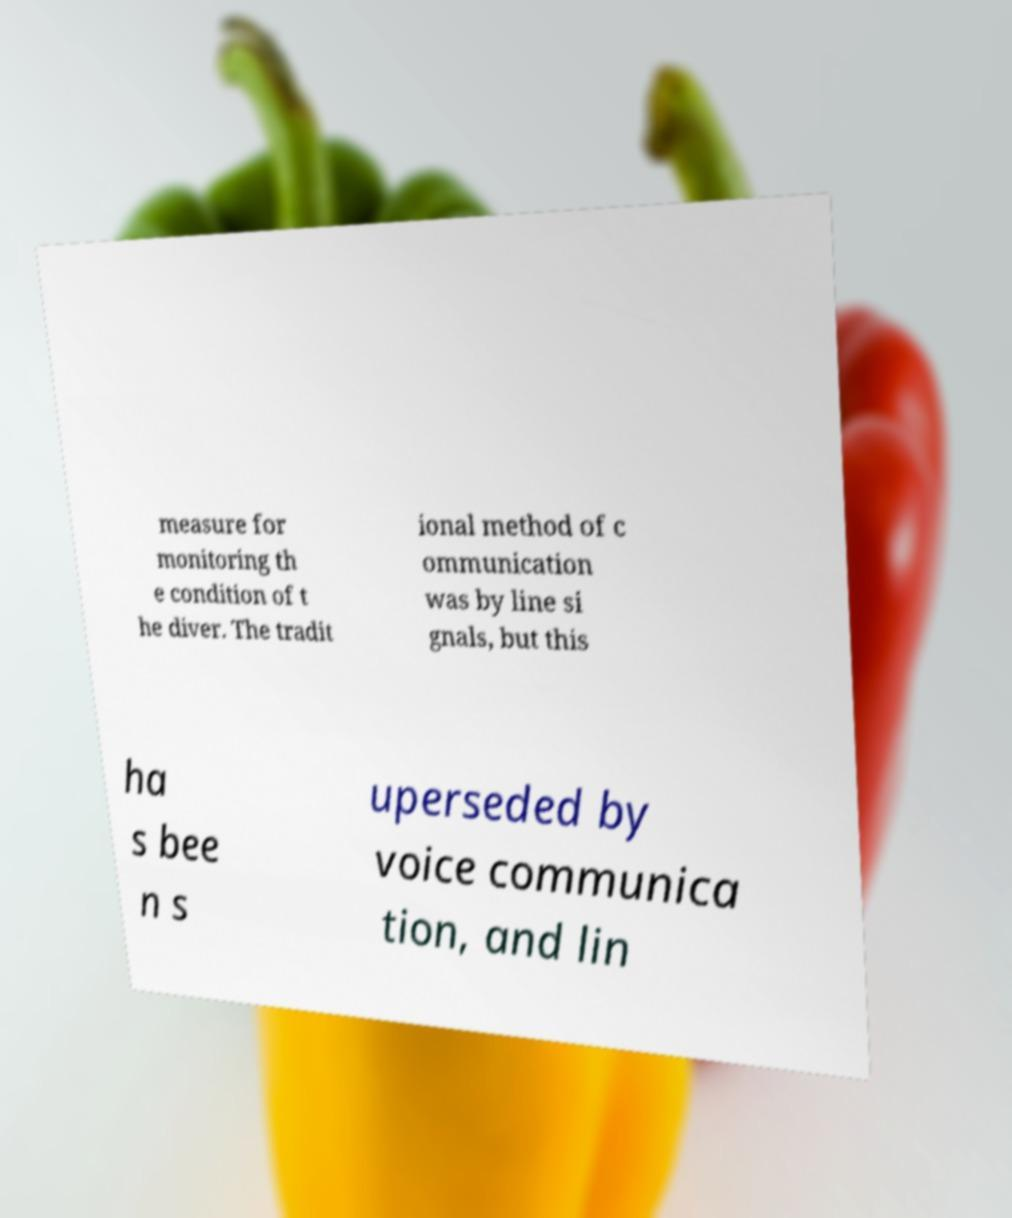Could you extract and type out the text from this image? measure for monitoring th e condition of t he diver. The tradit ional method of c ommunication was by line si gnals, but this ha s bee n s uperseded by voice communica tion, and lin 